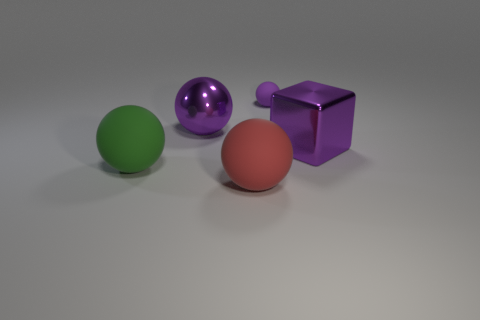Subtract all big purple spheres. How many spheres are left? 3 Add 5 small purple things. How many objects exist? 10 Subtract all green spheres. How many spheres are left? 3 Subtract all yellow blocks. How many purple balls are left? 2 Subtract all cubes. How many objects are left? 4 Subtract 1 blocks. How many blocks are left? 0 Add 5 tiny spheres. How many tiny spheres are left? 6 Add 5 big green cubes. How many big green cubes exist? 5 Subtract 0 gray cylinders. How many objects are left? 5 Subtract all gray spheres. Subtract all brown cubes. How many spheres are left? 4 